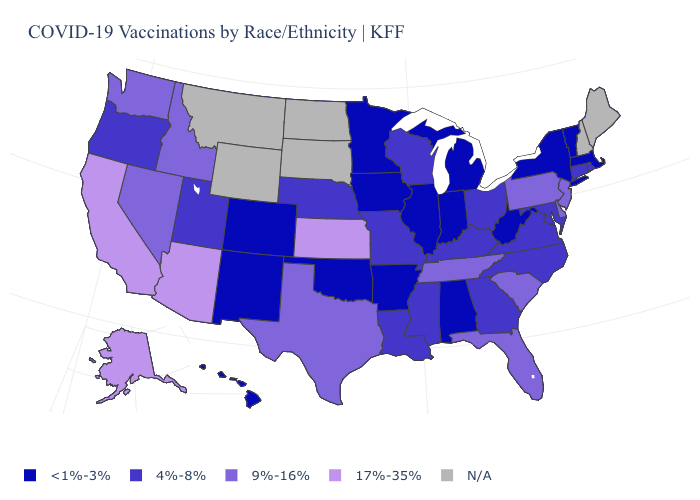Name the states that have a value in the range <1%-3%?
Keep it brief. Alabama, Arkansas, Colorado, Hawaii, Illinois, Indiana, Iowa, Massachusetts, Michigan, Minnesota, New Mexico, New York, Oklahoma, Vermont, West Virginia. Name the states that have a value in the range <1%-3%?
Concise answer only. Alabama, Arkansas, Colorado, Hawaii, Illinois, Indiana, Iowa, Massachusetts, Michigan, Minnesota, New Mexico, New York, Oklahoma, Vermont, West Virginia. Which states have the highest value in the USA?
Short answer required. Alaska, Arizona, California, Kansas. Which states have the lowest value in the MidWest?
Write a very short answer. Illinois, Indiana, Iowa, Michigan, Minnesota. What is the value of Kansas?
Concise answer only. 17%-35%. What is the value of South Carolina?
Be succinct. 9%-16%. Name the states that have a value in the range <1%-3%?
Give a very brief answer. Alabama, Arkansas, Colorado, Hawaii, Illinois, Indiana, Iowa, Massachusetts, Michigan, Minnesota, New Mexico, New York, Oklahoma, Vermont, West Virginia. Name the states that have a value in the range 17%-35%?
Quick response, please. Alaska, Arizona, California, Kansas. Among the states that border New Hampshire , which have the highest value?
Answer briefly. Massachusetts, Vermont. Does Rhode Island have the lowest value in the Northeast?
Answer briefly. No. Is the legend a continuous bar?
Short answer required. No. What is the value of Colorado?
Keep it brief. <1%-3%. What is the lowest value in the USA?
Keep it brief. <1%-3%. Which states have the lowest value in the South?
Keep it brief. Alabama, Arkansas, Oklahoma, West Virginia. Name the states that have a value in the range 9%-16%?
Give a very brief answer. Delaware, Florida, Idaho, Nevada, New Jersey, Pennsylvania, South Carolina, Tennessee, Texas, Washington. 